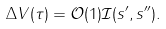<formula> <loc_0><loc_0><loc_500><loc_500>\Delta V ( \tau ) = \mathcal { O } ( 1 ) \mathcal { I } ( s ^ { \prime } , s ^ { \prime \prime } ) .</formula> 